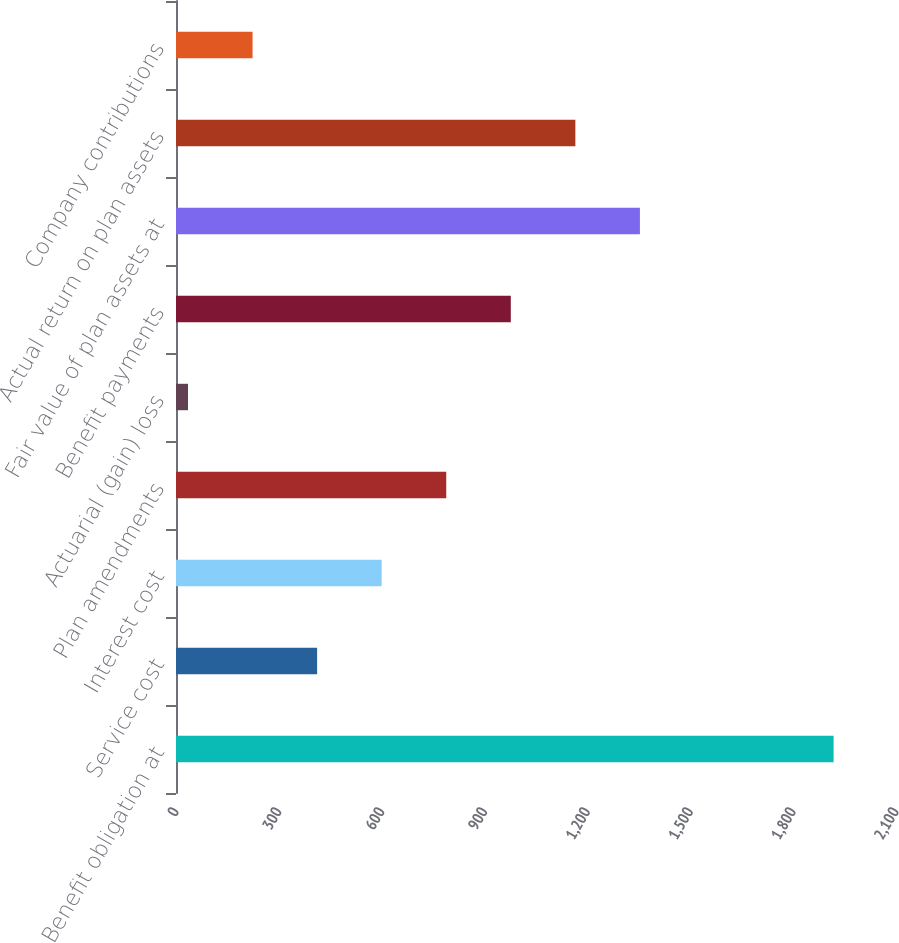<chart> <loc_0><loc_0><loc_500><loc_500><bar_chart><fcel>Benefit obligation at<fcel>Service cost<fcel>Interest cost<fcel>Plan amendments<fcel>Actuarial (gain) loss<fcel>Benefit payments<fcel>Fair value of plan assets at<fcel>Actual return on plan assets<fcel>Company contributions<nl><fcel>1918<fcel>411.6<fcel>599.9<fcel>788.2<fcel>35<fcel>976.5<fcel>1353.1<fcel>1164.8<fcel>223.3<nl></chart> 